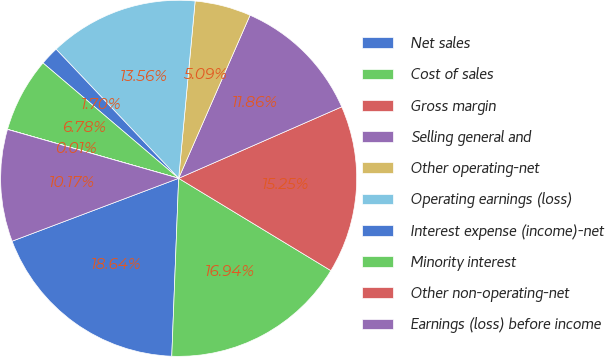<chart> <loc_0><loc_0><loc_500><loc_500><pie_chart><fcel>Net sales<fcel>Cost of sales<fcel>Gross margin<fcel>Selling general and<fcel>Other operating-net<fcel>Operating earnings (loss)<fcel>Interest expense (income)-net<fcel>Minority interest<fcel>Other non-operating-net<fcel>Earnings (loss) before income<nl><fcel>18.64%<fcel>16.94%<fcel>15.25%<fcel>11.86%<fcel>5.09%<fcel>13.56%<fcel>1.7%<fcel>6.78%<fcel>0.01%<fcel>10.17%<nl></chart> 